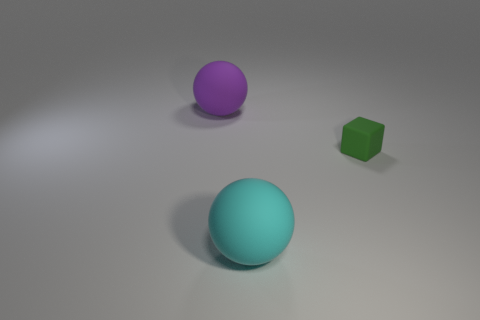Are there an equal number of balls that are left of the cyan sphere and blue metallic things?
Offer a terse response. No. What number of other small objects are the same material as the tiny thing?
Keep it short and to the point. 0. What color is the large thing that is the same material as the cyan sphere?
Provide a succinct answer. Purple. Is the shape of the big purple thing the same as the large cyan rubber object?
Ensure brevity in your answer.  Yes. Are there any big cyan rubber balls that are behind the big matte sphere that is in front of the sphere that is behind the cyan rubber ball?
Your answer should be compact. No. How many other small matte objects are the same color as the tiny object?
Your response must be concise. 0. There is a thing that is the same size as the cyan ball; what is its shape?
Make the answer very short. Sphere. There is a big purple rubber ball; are there any green things right of it?
Your answer should be compact. Yes. Do the purple thing and the cyan sphere have the same size?
Your response must be concise. Yes. There is a large matte object that is behind the large cyan sphere; what is its shape?
Offer a very short reply. Sphere. 